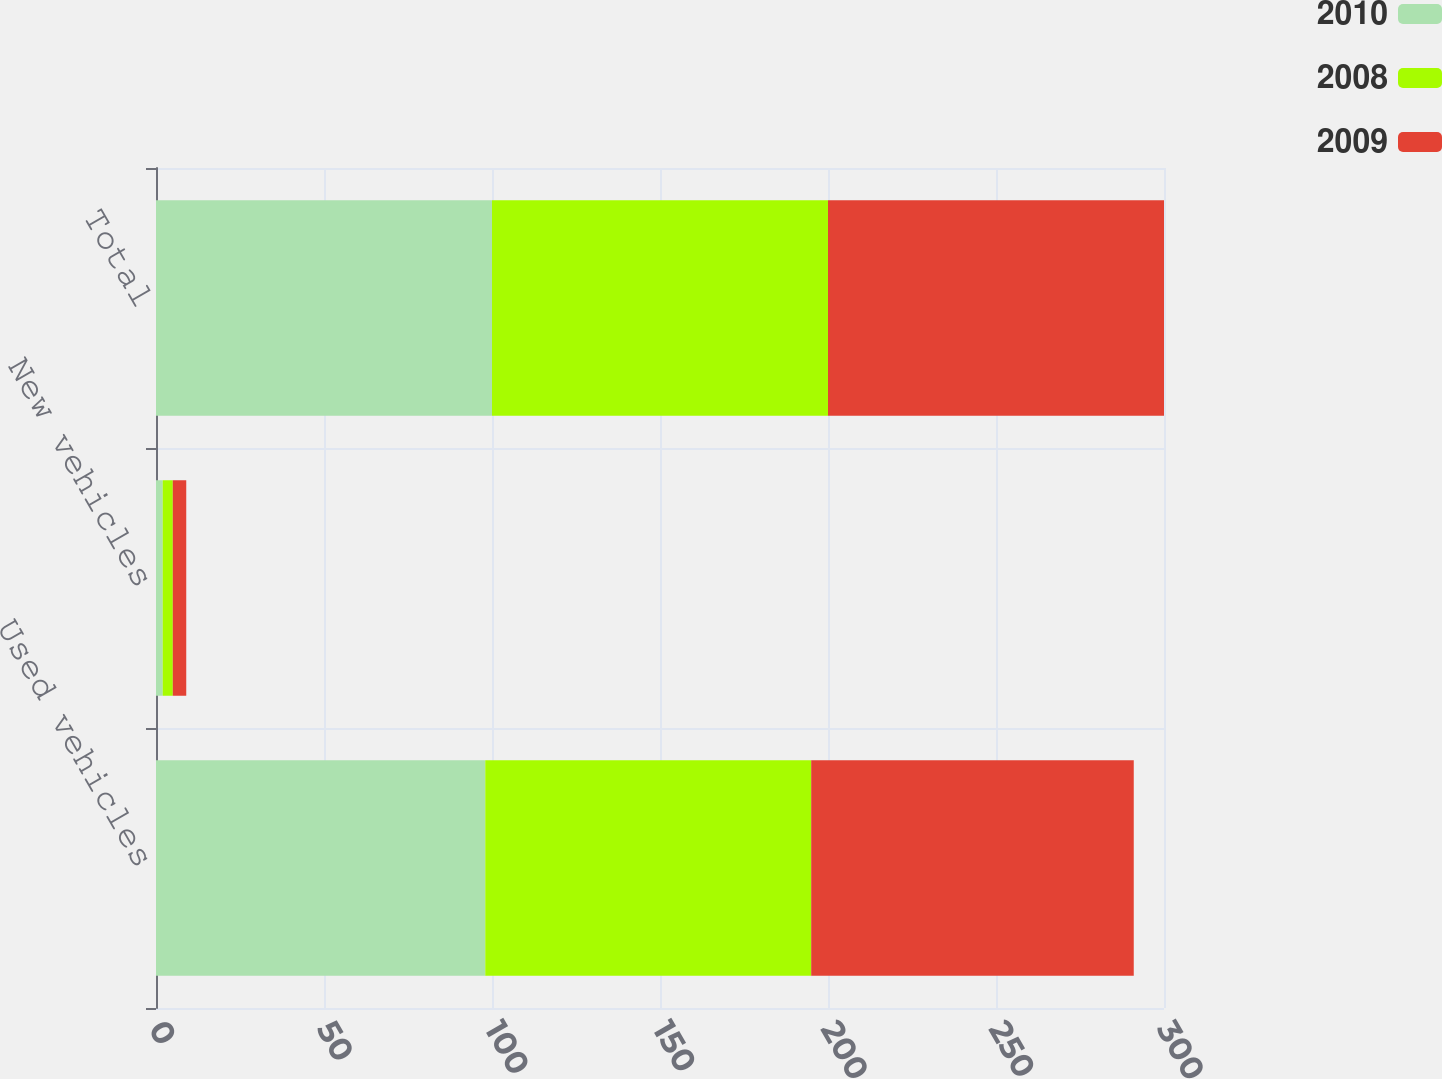Convert chart. <chart><loc_0><loc_0><loc_500><loc_500><stacked_bar_chart><ecel><fcel>Used vehicles<fcel>New vehicles<fcel>Total<nl><fcel>2010<fcel>98<fcel>2<fcel>100<nl><fcel>2008<fcel>97<fcel>3<fcel>100<nl><fcel>2009<fcel>96<fcel>4<fcel>100<nl></chart> 